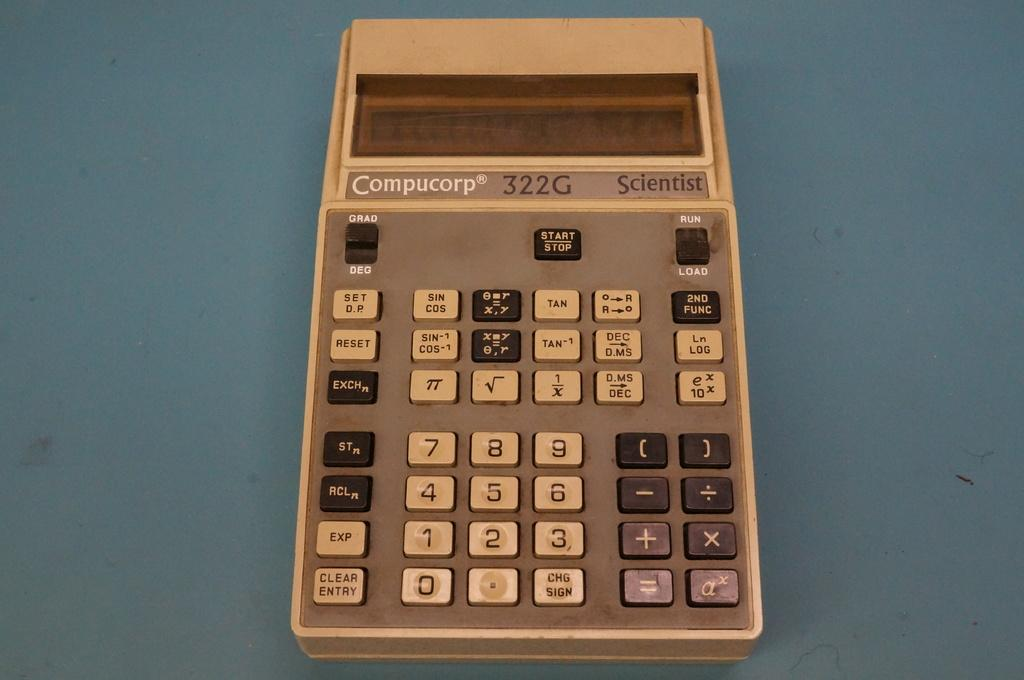<image>
Share a concise interpretation of the image provided. A Compucorp 322G calculator that is currently not displaying anything. 